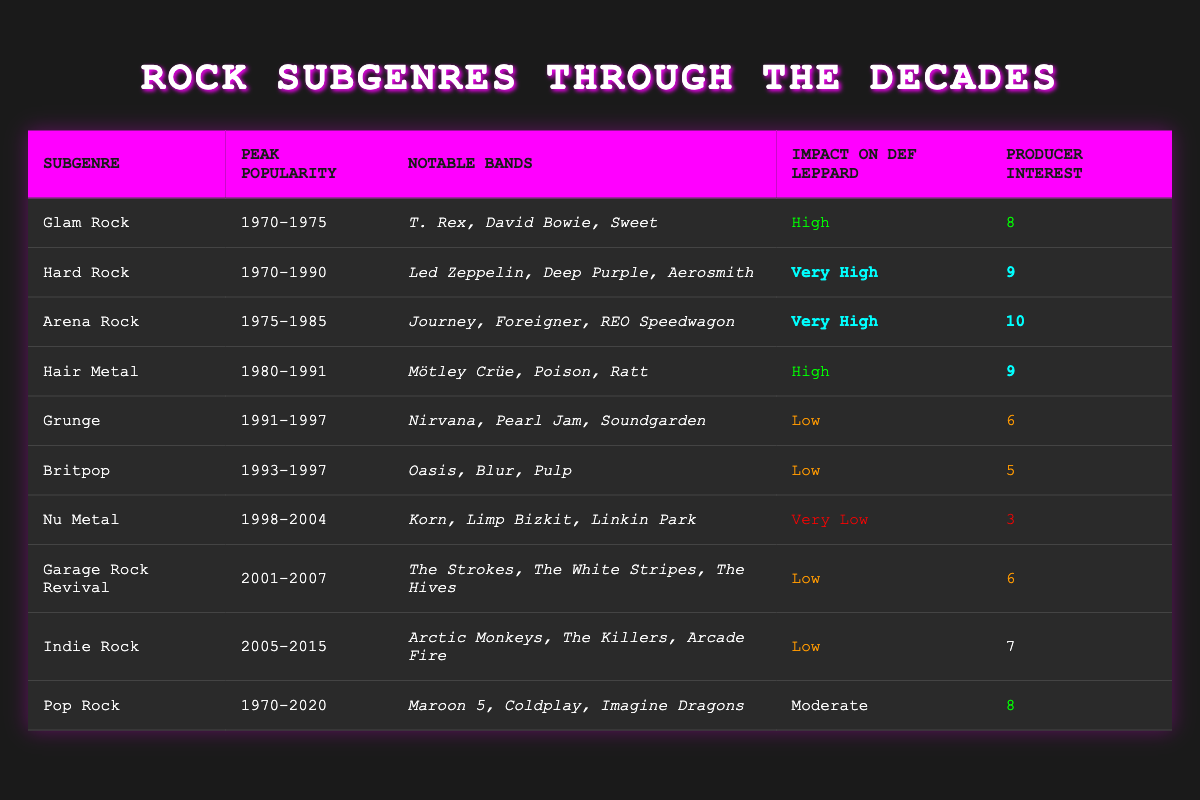What was the peak popularity period for Hair Metal? According to the table, the peak popularity for Hair Metal is listed as 1980-1991.
Answer: 1980-1991 Which rock subgenre has the highest producer interest rating? By examining the "Producer Interest" column, Arena Rock has the highest rating of 10.
Answer: Arena Rock Are there any rock subgenres that had a low impact on Def Leppard? Grunge, Britpop, and Nu Metal all have a "Low" or "Very Low" impact rating on Def Leppard.
Answer: Yes What is the average producer interest for the Glam Rock and Hard Rock subgenres? The ratings are 8 for Glam Rock and 9 for Hard Rock. The average is (8 + 9) / 2 = 8.5.
Answer: 8.5 Did any rock subgenre remain popular from 1970 to 2020? The "Pop Rock" subgenre has a peak popularity indicated as 1970-2020, meaning it remained popular over that entire timeframe.
Answer: Yes Which notable bands are associated with Arena Rock? The table lists Journey, Foreigner, and REO Speedwagon as notable bands in the Arena Rock category.
Answer: Journey, Foreigner, REO Speedwagon Is there a subgenre with both very high producer interest and high impact on Def Leppard? Arena Rock is the only subgenre that has a very high producer interest rating of 10 and also a very high impact on Def Leppard.
Answer: Yes What is the change in producer interest from Nu Metal to Hair Metal? Nu Metal has a producer interest of 3 while Hair Metal has a producer interest of 9. The change is 9 - 3 = 6.
Answer: 6 How many subgenres have an impact of "Very High"? Only two subgenres—Hard Rock and Arena Rock—are rated with "Very High" impact on Def Leppard.
Answer: 2 